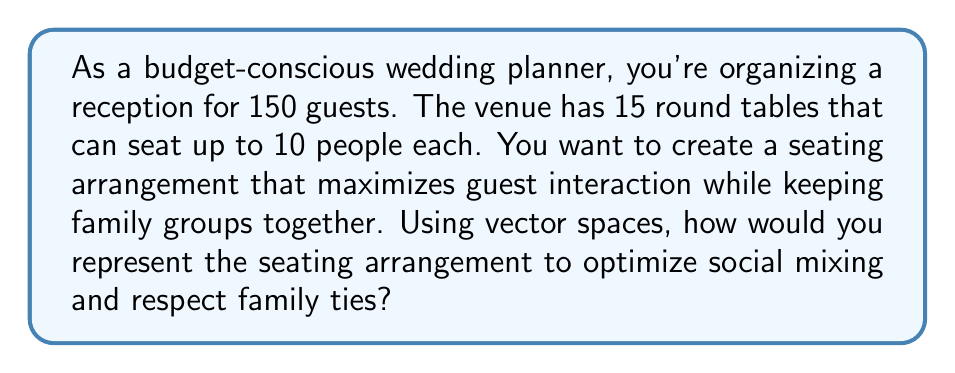Provide a solution to this math problem. To solve this problem using vector spaces, we can follow these steps:

1. Represent each table as a vector in a 150-dimensional space, where each dimension corresponds to a guest.

2. Let $\mathbf{t}_i$ represent the $i$-th table, where:
   $$\mathbf{t}_i = (t_{i1}, t_{i2}, ..., t_{i150})$$
   Here, $t_{ij} = 1$ if guest $j$ is seated at table $i$, and $t_{ij} = 0$ otherwise.

3. The constraint that each table can seat up to 10 people is represented by:
   $$\sum_{j=1}^{150} t_{ij} \leq 10 \quad \text{for all } i = 1, 2, ..., 15$$

4. To ensure every guest is seated, we need:
   $$\sum_{i=1}^{15} t_{ij} = 1 \quad \text{for all } j = 1, 2, ..., 150$$

5. To represent family groups, we can create a family matrix $\mathbf{F}$, where $F_{jk} = 1$ if guests $j$ and $k$ are from the same family, and 0 otherwise.

6. To maximize social mixing while respecting family ties, we can define an objective function:
   $$\text{Maximize} \sum_{i=1}^{15} \sum_{j=1}^{150} \sum_{k=1}^{150} t_{ij} t_{ik} (1 - F_{jk})$$

   This function encourages seating non-family members together.

7. To respect family ties, we add the constraint:
   $$t_{ij} + t_{ik} \leq 1 + F_{jk} \quad \text{for all } i, j, k$$

   This ensures that if two guests are not from the same family, they cannot be seated at the same table.

8. The optimal seating arrangement can be found by solving this integer programming problem, which can be done using various optimization algorithms.

The resulting vectors $\mathbf{t}_1, \mathbf{t}_2, ..., \mathbf{t}_{15}$ will represent the optimal seating arrangement, maximizing social interaction while respecting family ties.
Answer: The optimal seating arrangement is represented by 15 vectors $\mathbf{t}_1, \mathbf{t}_2, ..., \mathbf{t}_{15}$ in a 150-dimensional space, where each vector $\mathbf{t}_i$ corresponds to a table and each component represents whether a guest is seated at that table or not. These vectors satisfy the constraints and maximize the objective function described in the explanation. 